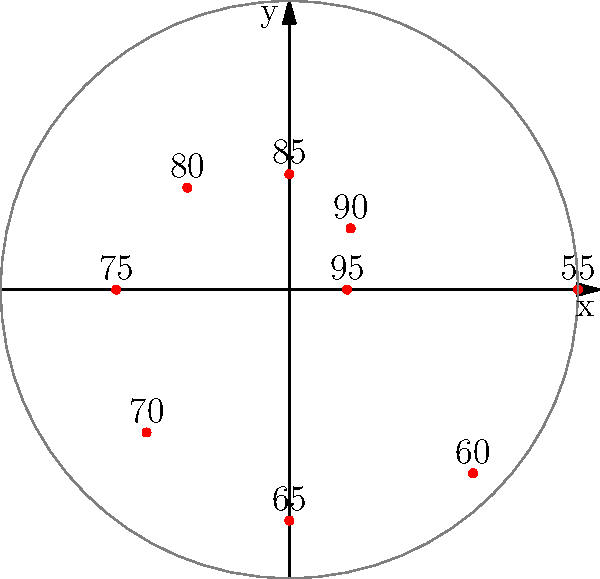Based on the polar scatter plot, which shows the relationship between distance from water sources (represented by the radius) and health outcomes (represented by the numbers next to each point), what is the general trend observed as the distance from water sources increases? To answer this question, we need to analyze the pattern in the polar scatter plot:

1. The radius (distance from the center) represents the distance from water sources.
2. The numbers next to each point represent health outcomes (higher numbers indicate better health).
3. We need to observe how health outcomes change as the radius increases.

Step-by-step analysis:
1. At the center (shortest distance), the health outcome is 95.
2. As we move outward (increasing distance):
   - At radius 3, health outcome is 90
   - At radius 4, health outcome is 85
   - At radius 5, health outcome is 80
   - And so on...
3. We can see that as the radius (distance) increases, the health outcome numbers consistently decrease.
4. The point farthest from the center (radius 10) has the lowest health outcome of 55.

This pattern clearly shows that as the distance from water sources increases, health outcomes generally decline.
Answer: Health outcomes decline as distance from water sources increases. 